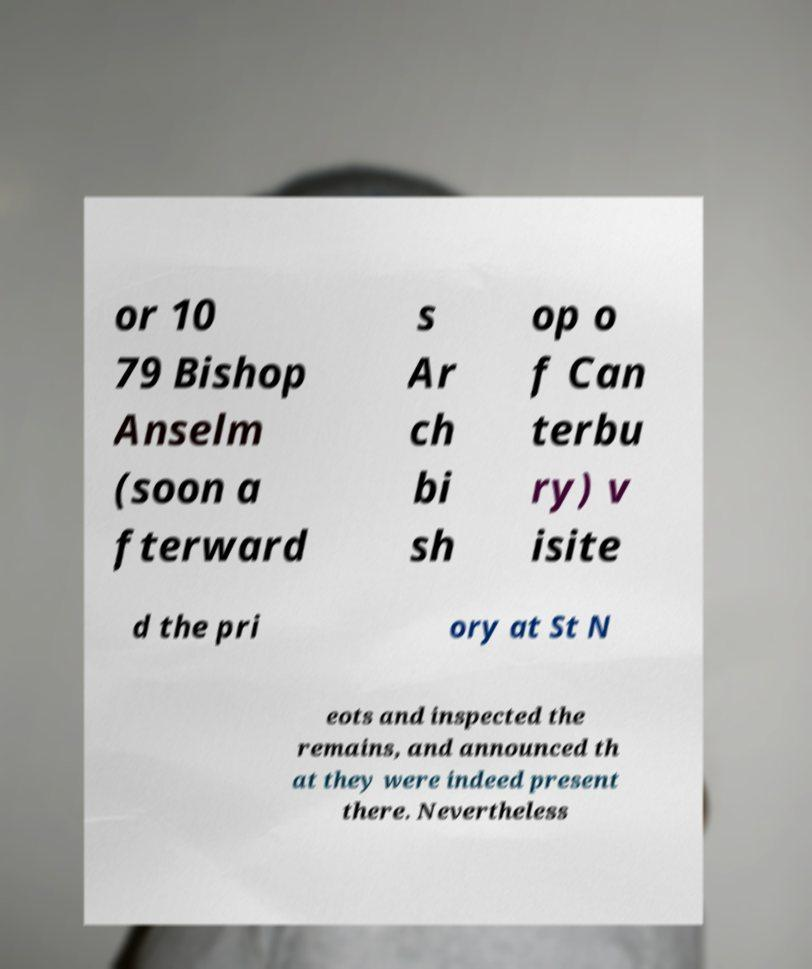Could you extract and type out the text from this image? or 10 79 Bishop Anselm (soon a fterward s Ar ch bi sh op o f Can terbu ry) v isite d the pri ory at St N eots and inspected the remains, and announced th at they were indeed present there. Nevertheless 